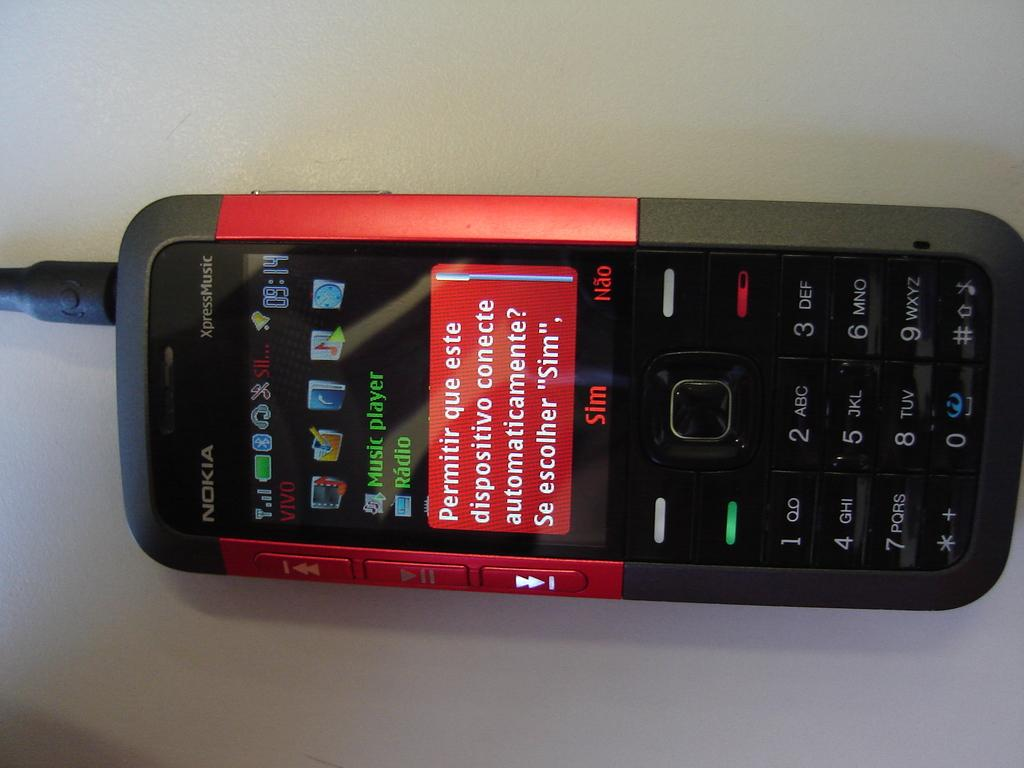<image>
Present a compact description of the photo's key features. Red and black cellphone on it's side and the words "Permitir que este" on the screen. 